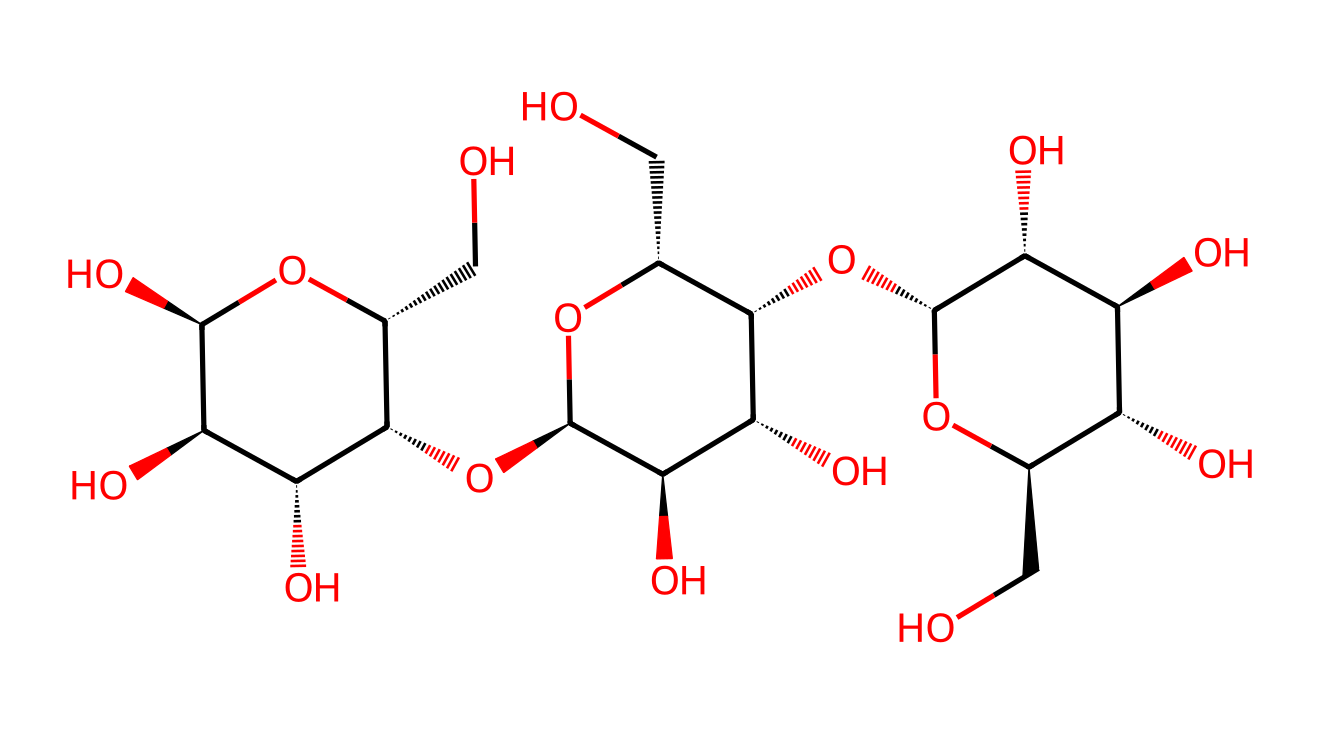What is the main component of this chemical structure? The chemical structure represents cellulose, which is a polysaccharide composed of glucose units that form the main component of plant cell walls.
Answer: cellulose How many oxygen atoms are present in this structure? By counting the depicted oxygen atoms in the cyclic structure, there are 6 oxygen atoms connected to the carbon skeleton.
Answer: 6 What kind of glycosidic bonds are found in this cellulose structure? The structure contains β-1,4-glycosidic bonds linking glucose monomers, which is typical for cellulose, hence contributing to its stiff and high-strength properties.
Answer: β-1,4-glycosidic What is the significance of this chemical in textile production? Cellulose is biodegradable, renewable, and provides strength, making it significant for eco-friendly textiles by reducing environmental impact compared to synthetic fibers.
Answer: eco-friendly How many carbon atoms are there in this chemical? The common composition of cellulose indicates that there are approximately 6 carbon atoms in each repeat unit of glucose, and considering the structure's complexity, I can count a total of 18 carbon atoms.
Answer: 18 What type of polymer is represented by this structure? This chemical structure is a natural polymer derived from plant materials, specifically being a structural polysaccharide.
Answer: polysaccharide Which feature of this chemical structure contributes to its insolubility in water? The extensive hydrogen bonding among the hydroxyl groups within the cellulose molecules contributes to its insolubility in water, due to the tightly packed structure.
Answer: hydrogen bonding 